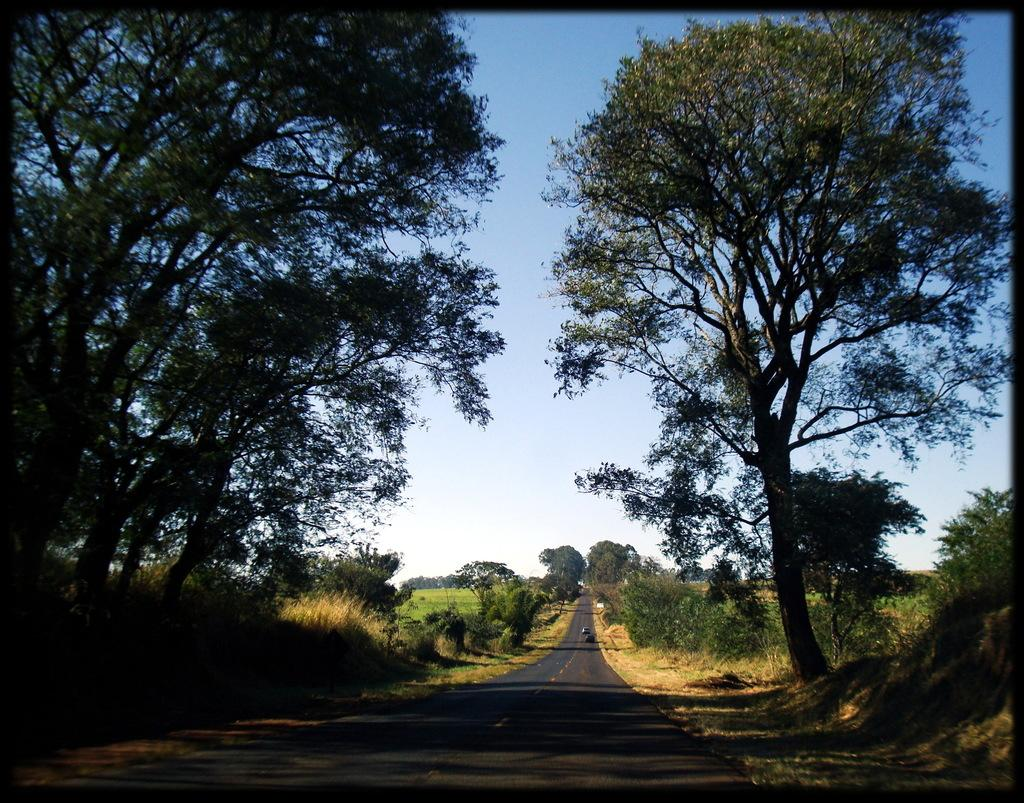What can be seen in the foreground of the image? There is a path in the foreground of the image. What surrounds the path in the image? There are trees on either side of the path. What type of vegetation is visible in the image? There is greenery visible in the image. What is visible at the top of the image? The sky is visible at the top of the image. What type of guitar is being played in the image? There is no guitar present in the image; it features a path with trees on either side and greenery. 